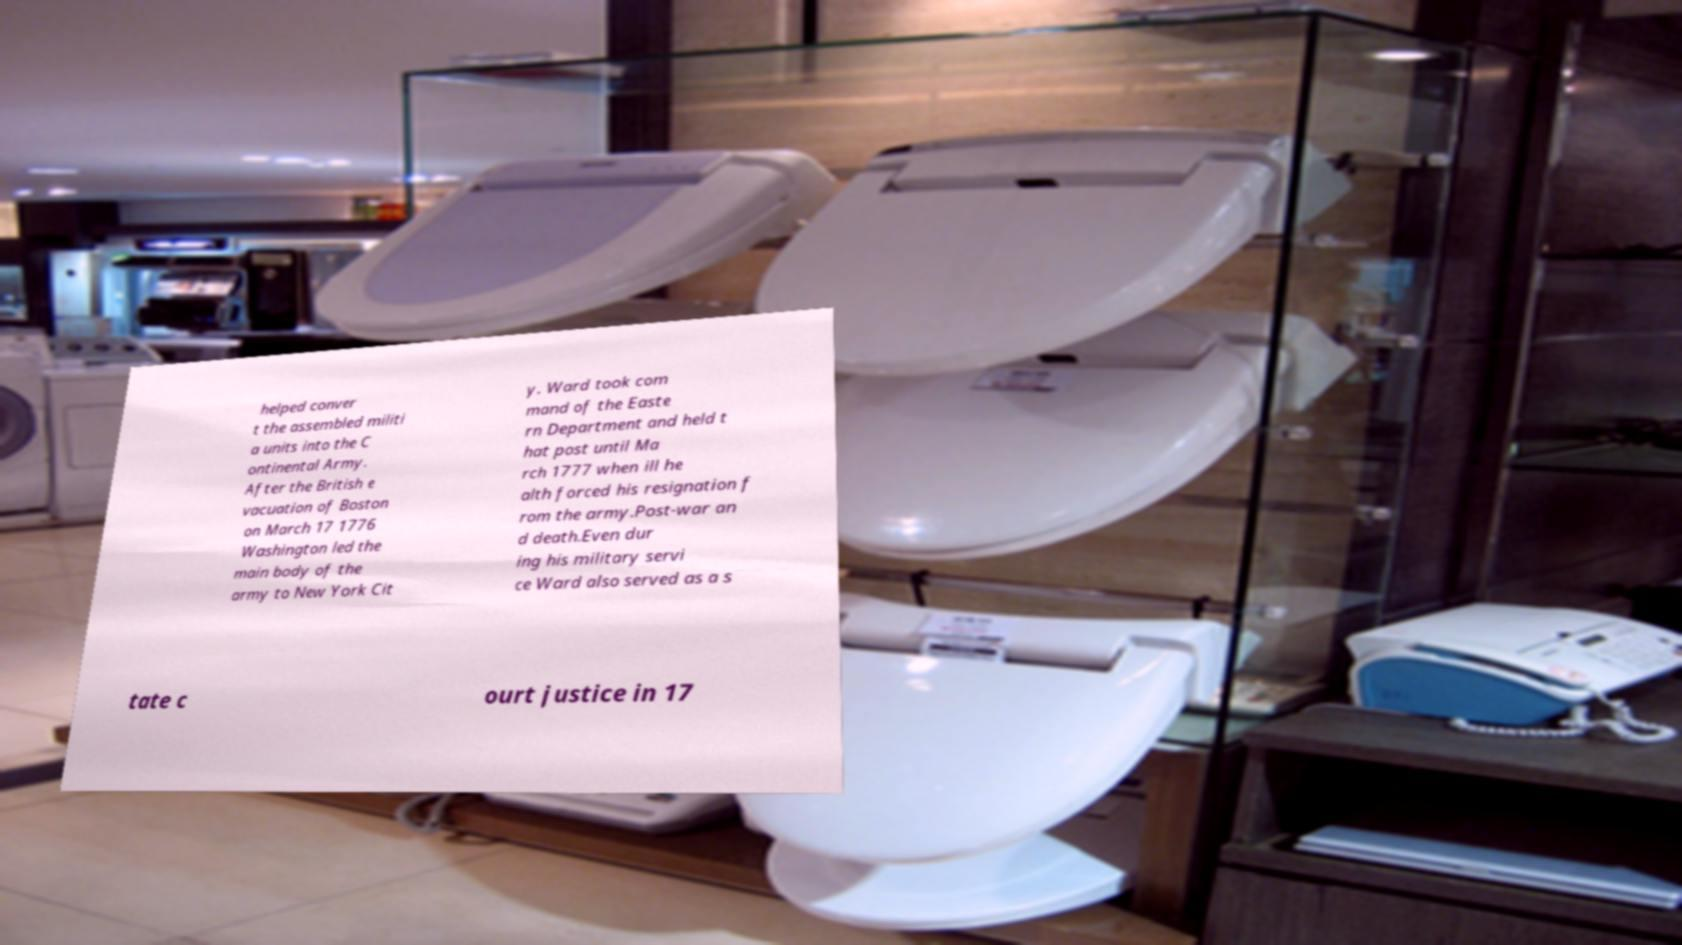Could you extract and type out the text from this image? helped conver t the assembled militi a units into the C ontinental Army. After the British e vacuation of Boston on March 17 1776 Washington led the main body of the army to New York Cit y. Ward took com mand of the Easte rn Department and held t hat post until Ma rch 1777 when ill he alth forced his resignation f rom the army.Post-war an d death.Even dur ing his military servi ce Ward also served as a s tate c ourt justice in 17 